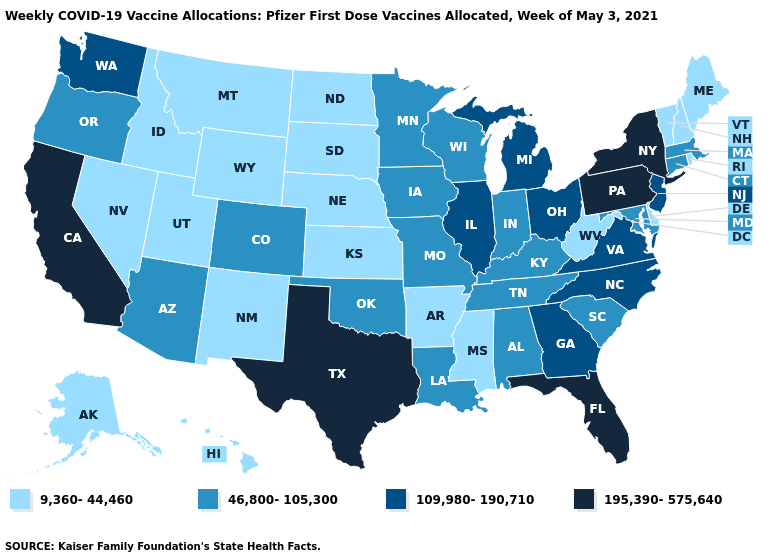What is the highest value in states that border New York?
Concise answer only. 195,390-575,640. Does Arizona have the lowest value in the West?
Answer briefly. No. Which states have the highest value in the USA?
Give a very brief answer. California, Florida, New York, Pennsylvania, Texas. Does Ohio have a higher value than Florida?
Quick response, please. No. Which states have the highest value in the USA?
Concise answer only. California, Florida, New York, Pennsylvania, Texas. What is the value of Illinois?
Be succinct. 109,980-190,710. Does New Hampshire have a higher value than New Mexico?
Keep it brief. No. What is the value of Indiana?
Keep it brief. 46,800-105,300. Name the states that have a value in the range 195,390-575,640?
Keep it brief. California, Florida, New York, Pennsylvania, Texas. Name the states that have a value in the range 46,800-105,300?
Keep it brief. Alabama, Arizona, Colorado, Connecticut, Indiana, Iowa, Kentucky, Louisiana, Maryland, Massachusetts, Minnesota, Missouri, Oklahoma, Oregon, South Carolina, Tennessee, Wisconsin. What is the value of Wyoming?
Short answer required. 9,360-44,460. Name the states that have a value in the range 46,800-105,300?
Quick response, please. Alabama, Arizona, Colorado, Connecticut, Indiana, Iowa, Kentucky, Louisiana, Maryland, Massachusetts, Minnesota, Missouri, Oklahoma, Oregon, South Carolina, Tennessee, Wisconsin. What is the value of Nebraska?
Give a very brief answer. 9,360-44,460. What is the value of Maryland?
Keep it brief. 46,800-105,300. What is the lowest value in states that border North Carolina?
Quick response, please. 46,800-105,300. 